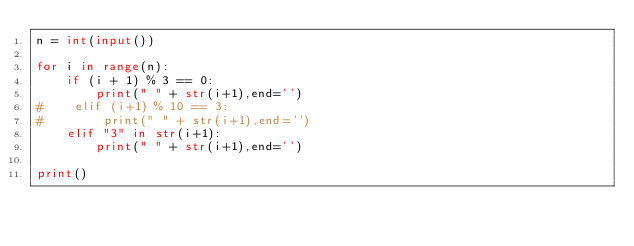<code> <loc_0><loc_0><loc_500><loc_500><_Python_>n = int(input())

for i in range(n):
    if (i + 1) % 3 == 0:
        print(" " + str(i+1),end='')
#    elif (i+1) % 10 == 3:
#        print(" " + str(i+1),end='')
    elif "3" in str(i+1):
        print(" " + str(i+1),end='')
        
print()
</code> 